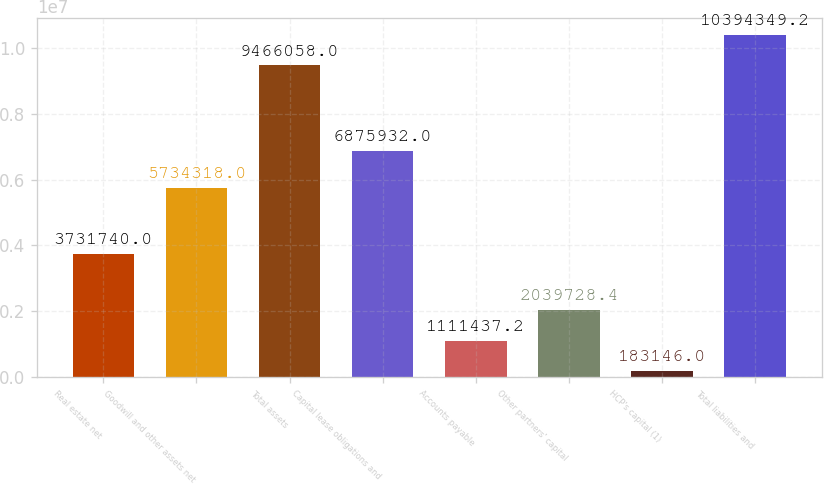Convert chart. <chart><loc_0><loc_0><loc_500><loc_500><bar_chart><fcel>Real estate net<fcel>Goodwill and other assets net<fcel>Total assets<fcel>Capital lease obligations and<fcel>Accounts payable<fcel>Other partners' capital<fcel>HCP's capital (1)<fcel>Total liabilities and<nl><fcel>3.73174e+06<fcel>5.73432e+06<fcel>9.46606e+06<fcel>6.87593e+06<fcel>1.11144e+06<fcel>2.03973e+06<fcel>183146<fcel>1.03943e+07<nl></chart> 